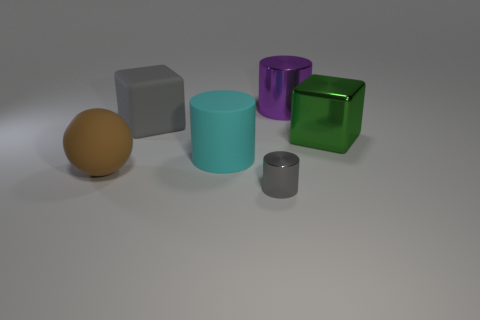Is there anything else that has the same size as the gray metal cylinder?
Provide a succinct answer. No. Does the green thing have the same material as the tiny thing?
Provide a short and direct response. Yes. How many other objects are the same size as the gray shiny cylinder?
Offer a terse response. 0. What color is the large cylinder to the left of the metal cylinder that is on the right side of the tiny cylinder?
Your answer should be compact. Cyan. What number of other things are there of the same shape as the green metallic thing?
Give a very brief answer. 1. Are there any large spheres that have the same material as the large gray object?
Offer a very short reply. Yes. There is a green block that is the same size as the gray cube; what material is it?
Offer a terse response. Metal. What color is the shiny cylinder behind the metal cylinder in front of the big matte object to the left of the gray rubber object?
Offer a very short reply. Purple. Is the shape of the gray thing to the left of the gray shiny object the same as the metal thing in front of the large green object?
Provide a short and direct response. No. What number of shiny things are there?
Offer a very short reply. 3. 